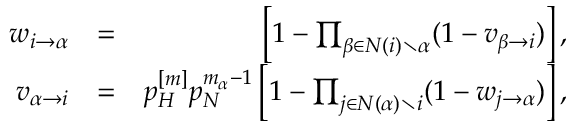<formula> <loc_0><loc_0><loc_500><loc_500>\begin{array} { r l r } { w _ { i \rightarrow \alpha } } & { = } & { \left [ 1 - \prod _ { \beta \in N ( i ) \ \alpha } ( 1 - v _ { \beta \rightarrow i } ) \right ] , } \\ { v _ { \alpha \rightarrow i } } & { = } & { p _ { H } ^ { [ m ] } p _ { N } ^ { m _ { \alpha } - 1 } \left [ 1 - \prod _ { j \in N ( \alpha ) \ i } ( 1 - w _ { j \rightarrow \alpha } ) \right ] , } \end{array}</formula> 